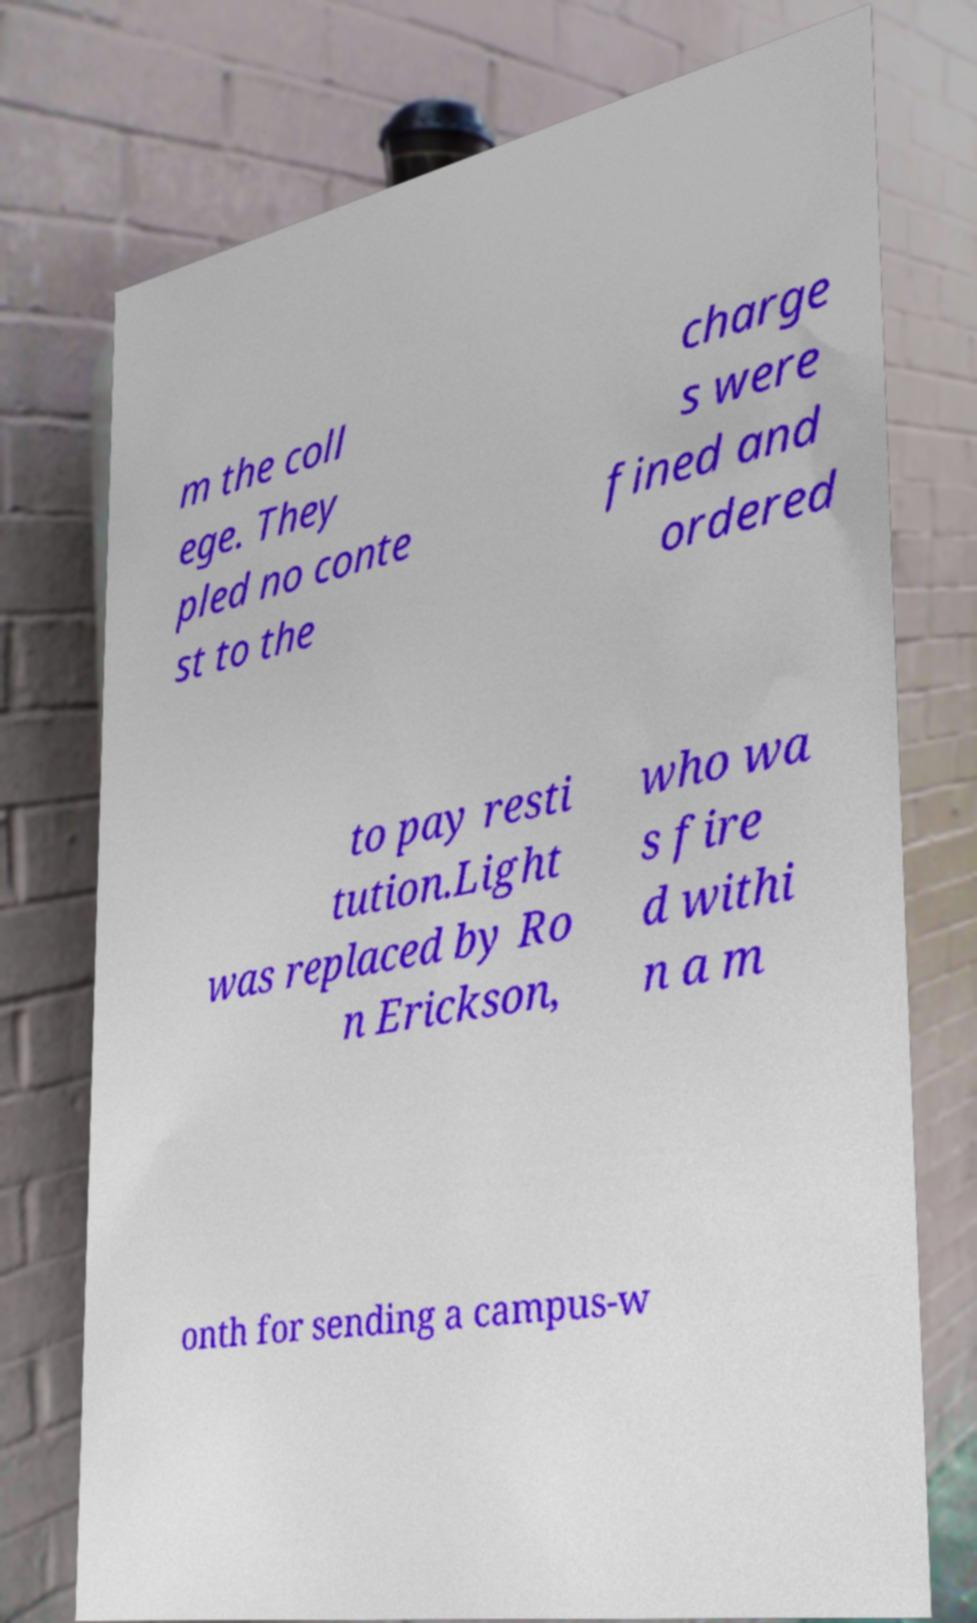Can you read and provide the text displayed in the image?This photo seems to have some interesting text. Can you extract and type it out for me? m the coll ege. They pled no conte st to the charge s were fined and ordered to pay resti tution.Light was replaced by Ro n Erickson, who wa s fire d withi n a m onth for sending a campus-w 